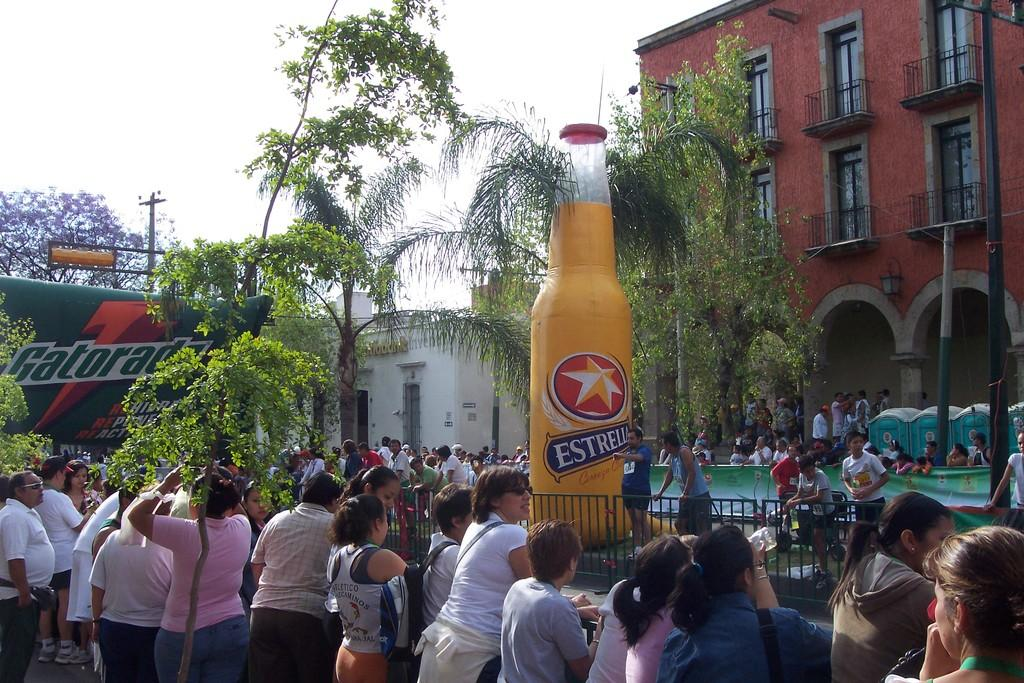<image>
Summarize the visual content of the image. a large estrella beer float among a group of people 